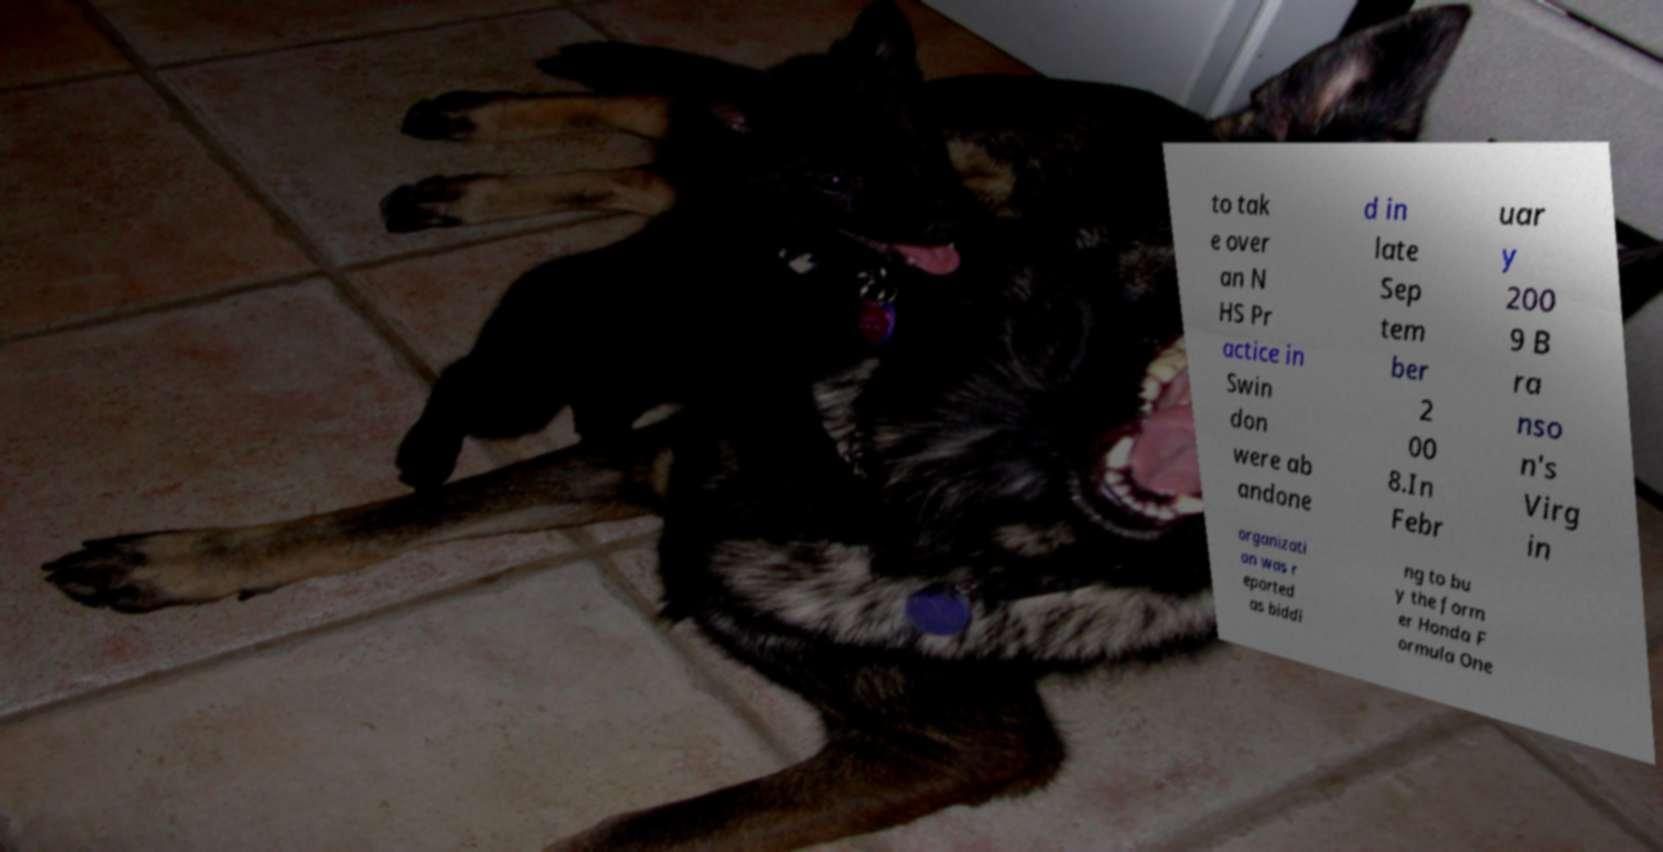Could you extract and type out the text from this image? to tak e over an N HS Pr actice in Swin don were ab andone d in late Sep tem ber 2 00 8.In Febr uar y 200 9 B ra nso n's Virg in organizati on was r eported as biddi ng to bu y the form er Honda F ormula One 